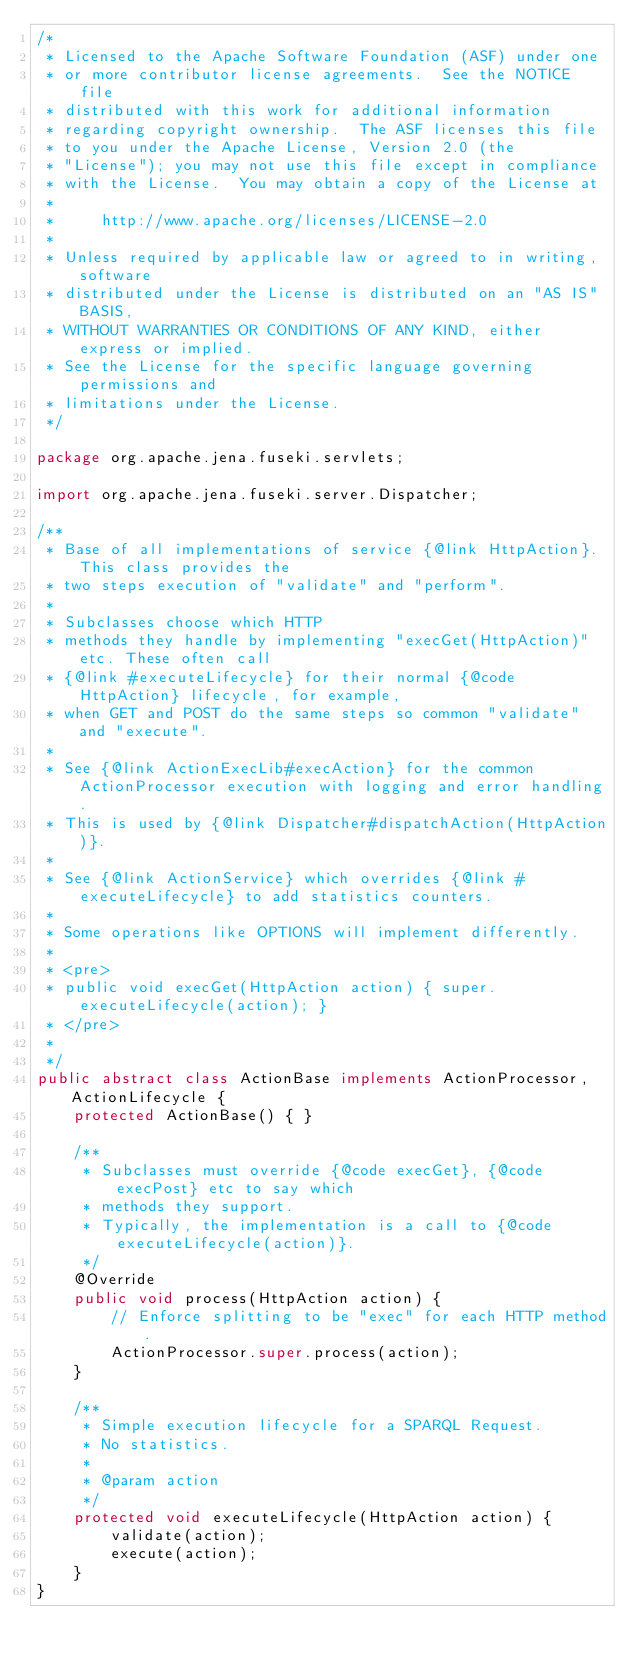<code> <loc_0><loc_0><loc_500><loc_500><_Java_>/*
 * Licensed to the Apache Software Foundation (ASF) under one
 * or more contributor license agreements.  See the NOTICE file
 * distributed with this work for additional information
 * regarding copyright ownership.  The ASF licenses this file
 * to you under the Apache License, Version 2.0 (the
 * "License"); you may not use this file except in compliance
 * with the License.  You may obtain a copy of the License at
 *
 *     http://www.apache.org/licenses/LICENSE-2.0
 *
 * Unless required by applicable law or agreed to in writing, software
 * distributed under the License is distributed on an "AS IS" BASIS,
 * WITHOUT WARRANTIES OR CONDITIONS OF ANY KIND, either express or implied.
 * See the License for the specific language governing permissions and
 * limitations under the License.
 */

package org.apache.jena.fuseki.servlets;

import org.apache.jena.fuseki.server.Dispatcher;

/**
 * Base of all implementations of service {@link HttpAction}. This class provides the
 * two steps execution of "validate" and "perform". 
 * 
 * Subclasses choose which HTTP
 * methods they handle by implementing "execGet(HttpAction)" etc. These often call
 * {@link #executeLifecycle} for their normal {@code HttpAction} lifecycle, for example,
 * when GET and POST do the same steps so common "validate" and "execute".
 * 
 * See {@link ActionExecLib#execAction} for the common ActionProcessor execution with logging and error handling.
 * This is used by {@link Dispatcher#dispatchAction(HttpAction)}.
 * 
 * See {@link ActionService} which overrides {@link #executeLifecycle} to add statistics counters.
 * 
 * Some operations like OPTIONS will implement differently.    
 * 
 * <pre>
 * public void execGet(HttpAction action) { super.executeLifecycle(action); }
 * </pre>  
 * 
 */
public abstract class ActionBase implements ActionProcessor, ActionLifecycle {
    protected ActionBase() { }

    /**
     * Subclasses must override {@code execGet}, {@code execPost} etc to say which
     * methods they support.
     * Typically, the implementation is a call to {@code executeLifecycle(action)}.
     */
    @Override
    public void process(HttpAction action) {
        // Enforce splitting to be "exec" for each HTTP method.
        ActionProcessor.super.process(action);
    }

    /**
     * Simple execution lifecycle for a SPARQL Request.
     * No statistics.
     *
     * @param action
     */
    protected void executeLifecycle(HttpAction action) {
        validate(action);
        execute(action);
    }
}
</code> 